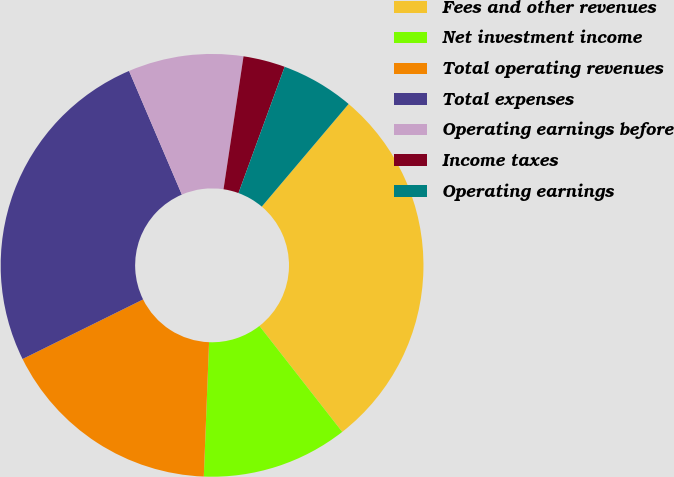Convert chart. <chart><loc_0><loc_0><loc_500><loc_500><pie_chart><fcel>Fees and other revenues<fcel>Net investment income<fcel>Total operating revenues<fcel>Total expenses<fcel>Operating earnings before<fcel>Income taxes<fcel>Operating earnings<nl><fcel>28.26%<fcel>11.18%<fcel>17.07%<fcel>25.88%<fcel>8.8%<fcel>3.2%<fcel>5.6%<nl></chart> 